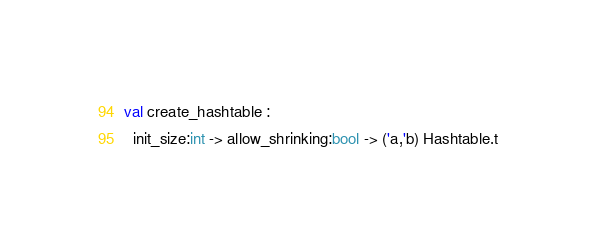<code> <loc_0><loc_0><loc_500><loc_500><_OCaml_>val create_hashtable :
  init_size:int -> allow_shrinking:bool -> ('a,'b) Hashtable.t
</code> 